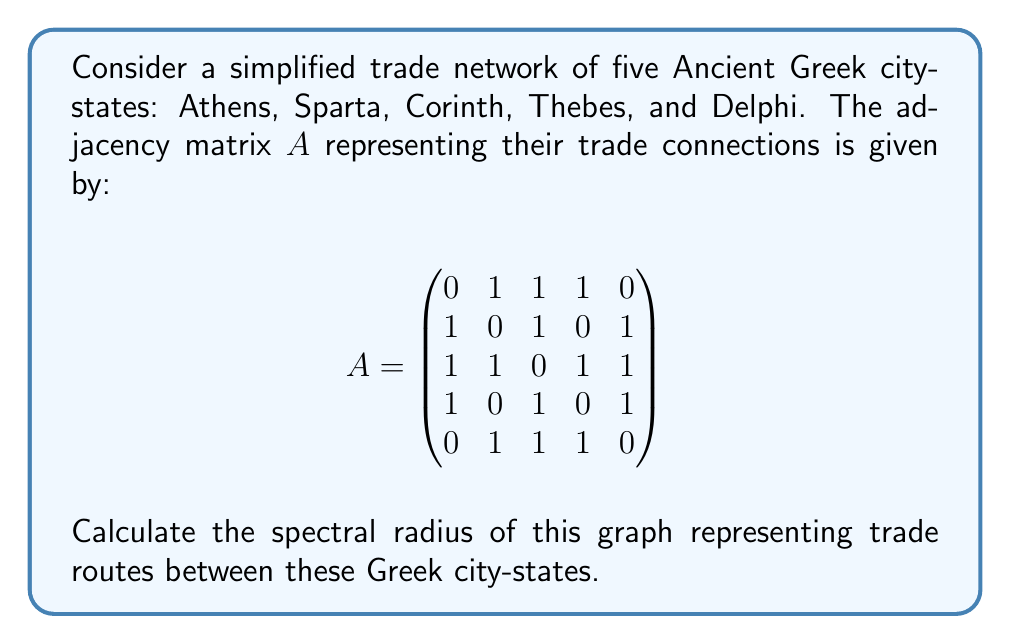Teach me how to tackle this problem. To find the spectral radius of the graph, we need to follow these steps:

1) The spectral radius is the largest absolute eigenvalue of the adjacency matrix $A$.

2) To find the eigenvalues, we need to solve the characteristic equation:
   $\det(A - \lambda I) = 0$, where $I$ is the $5 \times 5$ identity matrix.

3) Expanding the determinant:
   $$\det(A - \lambda I) = \begin{vmatrix}
   -\lambda & 1 & 1 & 1 & 0 \\
   1 & -\lambda & 1 & 0 & 1 \\
   1 & 1 & -\lambda & 1 & 1 \\
   1 & 0 & 1 & -\lambda & 1 \\
   0 & 1 & 1 & 1 & -\lambda
   \end{vmatrix} = 0$$

4) Solving this equation gives us the characteristic polynomial:
   $\lambda^5 - 10\lambda^3 - 8\lambda^2 + 5\lambda + 4 = 0$

5) The roots of this polynomial are the eigenvalues. Using numerical methods, we can find that the eigenvalues are approximately:
   $\lambda_1 \approx 2.7321$
   $\lambda_2 \approx -1.7321$
   $\lambda_3 \approx 0.7321$
   $\lambda_4 \approx -0.7321$
   $\lambda_5 = 0$

6) The spectral radius is the largest absolute value among these eigenvalues, which is $|\lambda_1| \approx 2.7321$.

7) This value is actually exactly $1 + \sqrt{3}$, which can be verified algebraically.
Answer: $1 + \sqrt{3}$ 